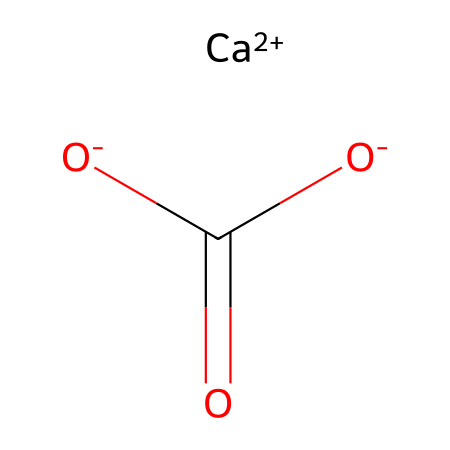What is the main cation present in this chemical? The chemical structure includes [Ca+2], indicating that calcium is the main cation present. The "+2" signifies its oxidation state.
Answer: calcium How many oxygen atoms are in this chemical? Observing the structure, there are three oxygen atoms indicated by the three occurrences of "O" in the chemical formula.
Answer: three What type of compound is represented by this chemical structure? The presence of calcium, along with the phosphate group structure, points to this being a mineral compound, specifically a type of inorganic compound known as a carbonate.
Answer: carbonate What is the charge of the calcium ion in this chemical? The chemical includes [Ca+2], revealing that the calcium ion has a +2 charge, which is indicated by the superscript “+2.”
Answer: +2 How many total atoms are present in the chemical composition? Counting all the atoms: one calcium, one carbon, three oxygen atoms gives a total of five atoms present in the structure.
Answer: five What role does calcium play in the chemical's structure? Calcium acts as the central cation that balances the charge of the negatively charged oxygen atoms and contributes to the mineral's structural integrity.
Answer: central cation What type of bonding is likely present in this molecule? The molecule likely possesses ionic bonding due to the presence of charged ions (e.g., calcium ion with a +2 charge and negatively charged oxygen atoms).
Answer: ionic bonding 